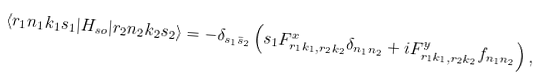<formula> <loc_0><loc_0><loc_500><loc_500>\langle r _ { 1 } n _ { 1 } k _ { 1 } s _ { 1 } | H _ { s o } | r _ { 2 } n _ { 2 } k _ { 2 } s _ { 2 } \rangle = - \delta _ { s _ { 1 } \bar { s } _ { 2 } } \left ( s _ { 1 } F ^ { x } _ { r _ { 1 } k _ { 1 } , r _ { 2 } k _ { 2 } } \delta _ { n _ { 1 } n _ { 2 } } + i F ^ { y } _ { r _ { 1 } k _ { 1 } , r _ { 2 } k _ { 2 } } f _ { n _ { 1 } n _ { 2 } } \right ) ,</formula> 